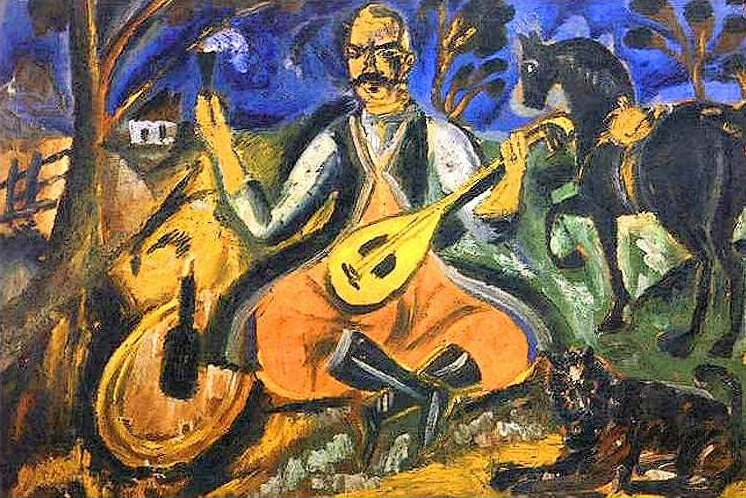What role does the dog play in this composition? The black dog serves as a symbol of loyalty and companionship, reinforcing the painting’s theme of serenity and grounding the scene in everyday life. By its placement at the man's feet, it also helps draw the viewer's eye to the central figure, the musician, linking human emotion and nature. 